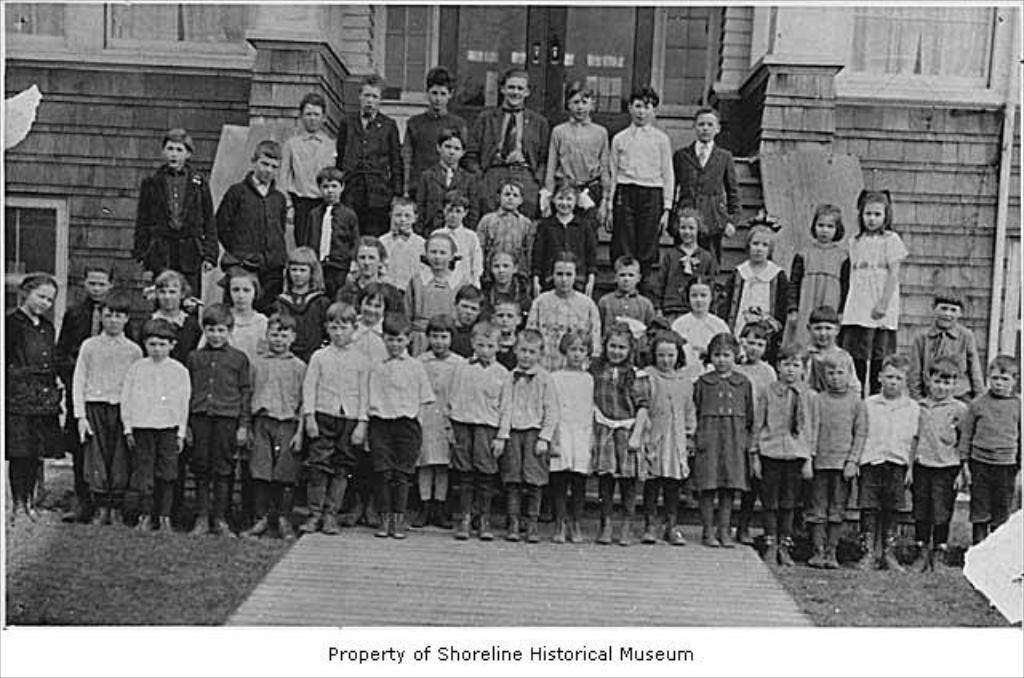What is the color scheme of the image? The image is black and white. How many kids are in the image? There are multiple kids in the image. What are the kids doing in the image? The kids are posing for a group picture. What can be seen in the background of the image? There is a building in the background of the image. What feature of the building is mentioned in the facts? The building has doors. How many cacti can be seen in the image? There are no cacti present in the image. What unit of measurement is used to determine the size of the building in the image? The facts provided do not mention any specific unit of measurement for the building's size. 